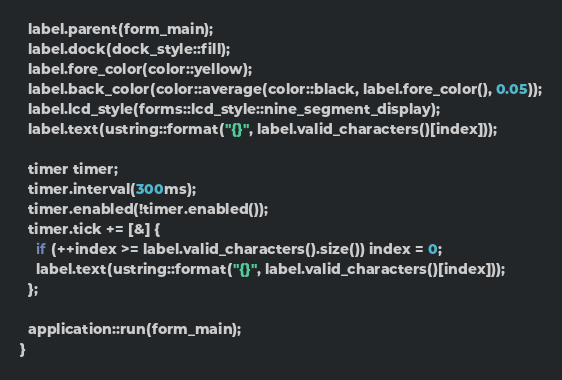Convert code to text. <code><loc_0><loc_0><loc_500><loc_500><_C++_>  label.parent(form_main);
  label.dock(dock_style::fill);
  label.fore_color(color::yellow);
  label.back_color(color::average(color::black, label.fore_color(), 0.05));
  label.lcd_style(forms::lcd_style::nine_segment_display);
  label.text(ustring::format("{}", label.valid_characters()[index]));

  timer timer;
  timer.interval(300ms);
  timer.enabled(!timer.enabled());
  timer.tick += [&] {
    if (++index >= label.valid_characters().size()) index = 0;
    label.text(ustring::format("{}", label.valid_characters()[index]));
  };

  application::run(form_main);
}
</code> 